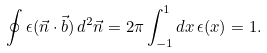Convert formula to latex. <formula><loc_0><loc_0><loc_500><loc_500>\oint \epsilon ( \vec { n } \cdot \vec { b } ) \, d ^ { 2 } \vec { n } = 2 \pi \int _ { - 1 } ^ { 1 } d x \, \epsilon ( x ) = 1 .</formula> 